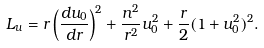<formula> <loc_0><loc_0><loc_500><loc_500>L _ { u } = r \left ( \frac { d u _ { 0 } } { d r } \right ) ^ { 2 } + \frac { n ^ { 2 } } { r ^ { 2 } } u ^ { 2 } _ { 0 } + \frac { r } { 2 } ( 1 + u ^ { 2 } _ { 0 } ) ^ { 2 } .</formula> 